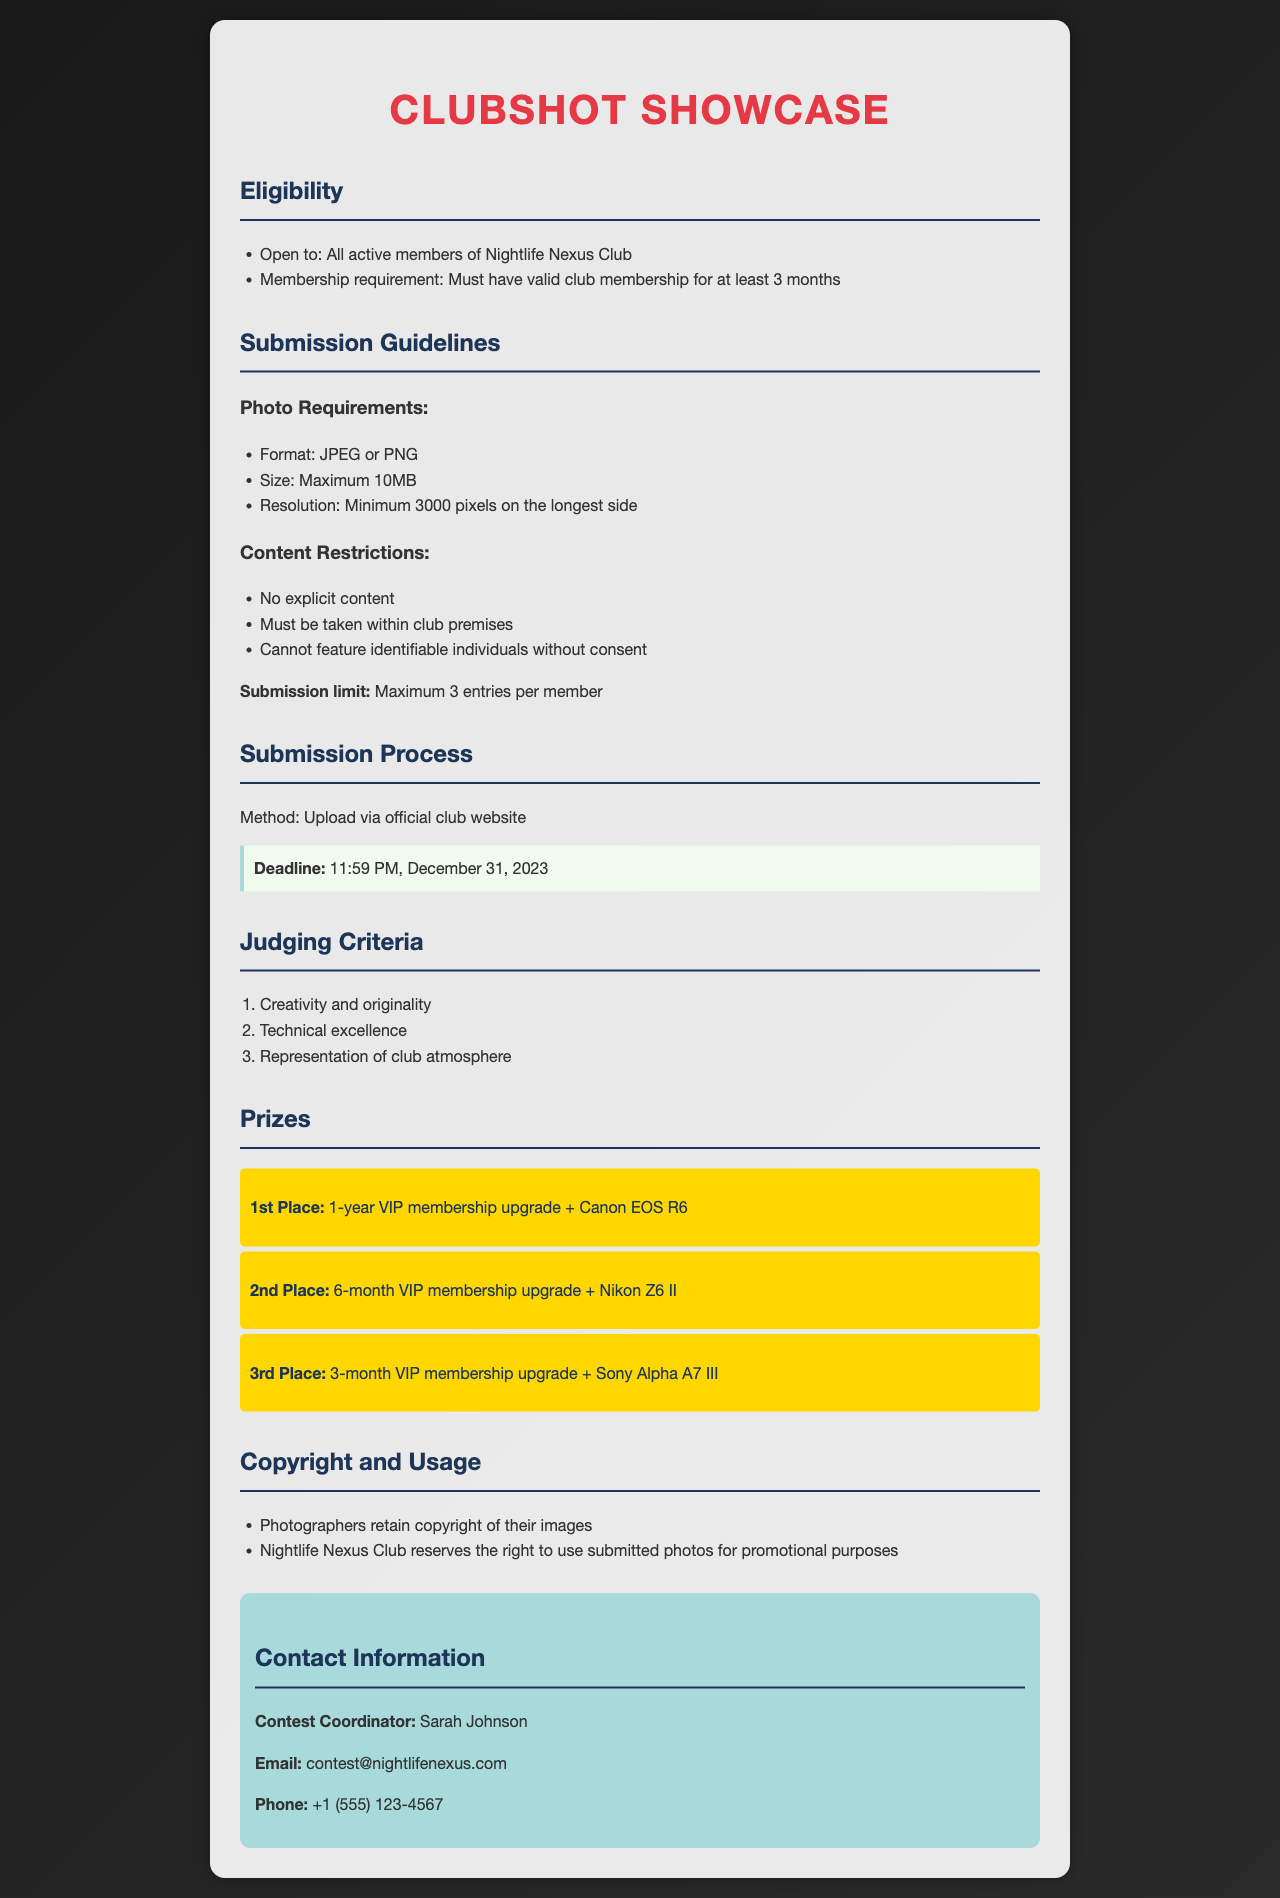What is the submission deadline? The submission deadline is stated explicitly in the document, indicating the cut-off time for entries.
Answer: 11:59 PM, December 31, 2023 Who is the contest coordinator? The document provides the name of the individual responsible for coordinating the contest, which is mentioned under contact information.
Answer: Sarah Johnson What is the maximum file size for submissions? The document specifies the maximum file size allowed for photo submissions, which helps participants understand submission limits.
Answer: Maximum 10MB What is the first-place prize? The document describes the prizes awarded for different placements, detailing what the first-place winner receives.
Answer: 1-year VIP membership upgrade + Canon EOS R6 How many entries can each member submit? The document outlines a limitation on the number of submissions, which ensures fairness in the contest.
Answer: Maximum 3 entries per member What two formats are acceptable for submissions? The document lists the required formats for photo submissions, guiding participants on how to prepare their files.
Answer: JPEG or PNG Which criteria are evaluated during judging? The document details the criteria used by judges to assess the submitted photographs, helping participants understand what they should focus on.
Answer: Creativity and originality, Technical excellence, Representation of club atmosphere What are the content restrictions for the photos? The document explains the rules concerning the content of submitted images, critical for ensuring compliance with club policies.
Answer: No explicit content, Must be taken within club premises, Cannot feature identifiable individuals without consent 